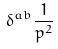Convert formula to latex. <formula><loc_0><loc_0><loc_500><loc_500>\delta ^ { a b } \frac { 1 } { p ^ { 2 } }</formula> 